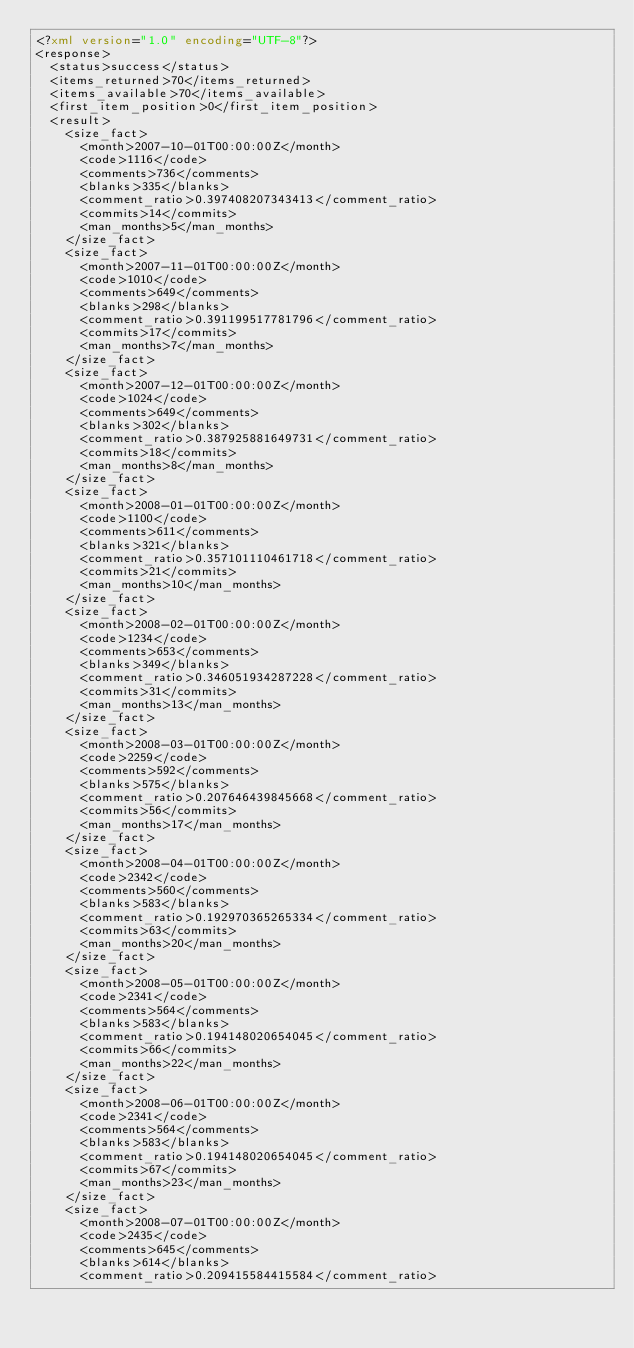Convert code to text. <code><loc_0><loc_0><loc_500><loc_500><_XML_><?xml version="1.0" encoding="UTF-8"?>
<response>
  <status>success</status>
  <items_returned>70</items_returned>
  <items_available>70</items_available>
  <first_item_position>0</first_item_position>
  <result>
    <size_fact>
      <month>2007-10-01T00:00:00Z</month>
      <code>1116</code>
      <comments>736</comments>
      <blanks>335</blanks>
      <comment_ratio>0.397408207343413</comment_ratio>
      <commits>14</commits>
      <man_months>5</man_months>
    </size_fact>
    <size_fact>
      <month>2007-11-01T00:00:00Z</month>
      <code>1010</code>
      <comments>649</comments>
      <blanks>298</blanks>
      <comment_ratio>0.391199517781796</comment_ratio>
      <commits>17</commits>
      <man_months>7</man_months>
    </size_fact>
    <size_fact>
      <month>2007-12-01T00:00:00Z</month>
      <code>1024</code>
      <comments>649</comments>
      <blanks>302</blanks>
      <comment_ratio>0.387925881649731</comment_ratio>
      <commits>18</commits>
      <man_months>8</man_months>
    </size_fact>
    <size_fact>
      <month>2008-01-01T00:00:00Z</month>
      <code>1100</code>
      <comments>611</comments>
      <blanks>321</blanks>
      <comment_ratio>0.357101110461718</comment_ratio>
      <commits>21</commits>
      <man_months>10</man_months>
    </size_fact>
    <size_fact>
      <month>2008-02-01T00:00:00Z</month>
      <code>1234</code>
      <comments>653</comments>
      <blanks>349</blanks>
      <comment_ratio>0.346051934287228</comment_ratio>
      <commits>31</commits>
      <man_months>13</man_months>
    </size_fact>
    <size_fact>
      <month>2008-03-01T00:00:00Z</month>
      <code>2259</code>
      <comments>592</comments>
      <blanks>575</blanks>
      <comment_ratio>0.207646439845668</comment_ratio>
      <commits>56</commits>
      <man_months>17</man_months>
    </size_fact>
    <size_fact>
      <month>2008-04-01T00:00:00Z</month>
      <code>2342</code>
      <comments>560</comments>
      <blanks>583</blanks>
      <comment_ratio>0.192970365265334</comment_ratio>
      <commits>63</commits>
      <man_months>20</man_months>
    </size_fact>
    <size_fact>
      <month>2008-05-01T00:00:00Z</month>
      <code>2341</code>
      <comments>564</comments>
      <blanks>583</blanks>
      <comment_ratio>0.194148020654045</comment_ratio>
      <commits>66</commits>
      <man_months>22</man_months>
    </size_fact>
    <size_fact>
      <month>2008-06-01T00:00:00Z</month>
      <code>2341</code>
      <comments>564</comments>
      <blanks>583</blanks>
      <comment_ratio>0.194148020654045</comment_ratio>
      <commits>67</commits>
      <man_months>23</man_months>
    </size_fact>
    <size_fact>
      <month>2008-07-01T00:00:00Z</month>
      <code>2435</code>
      <comments>645</comments>
      <blanks>614</blanks>
      <comment_ratio>0.209415584415584</comment_ratio></code> 